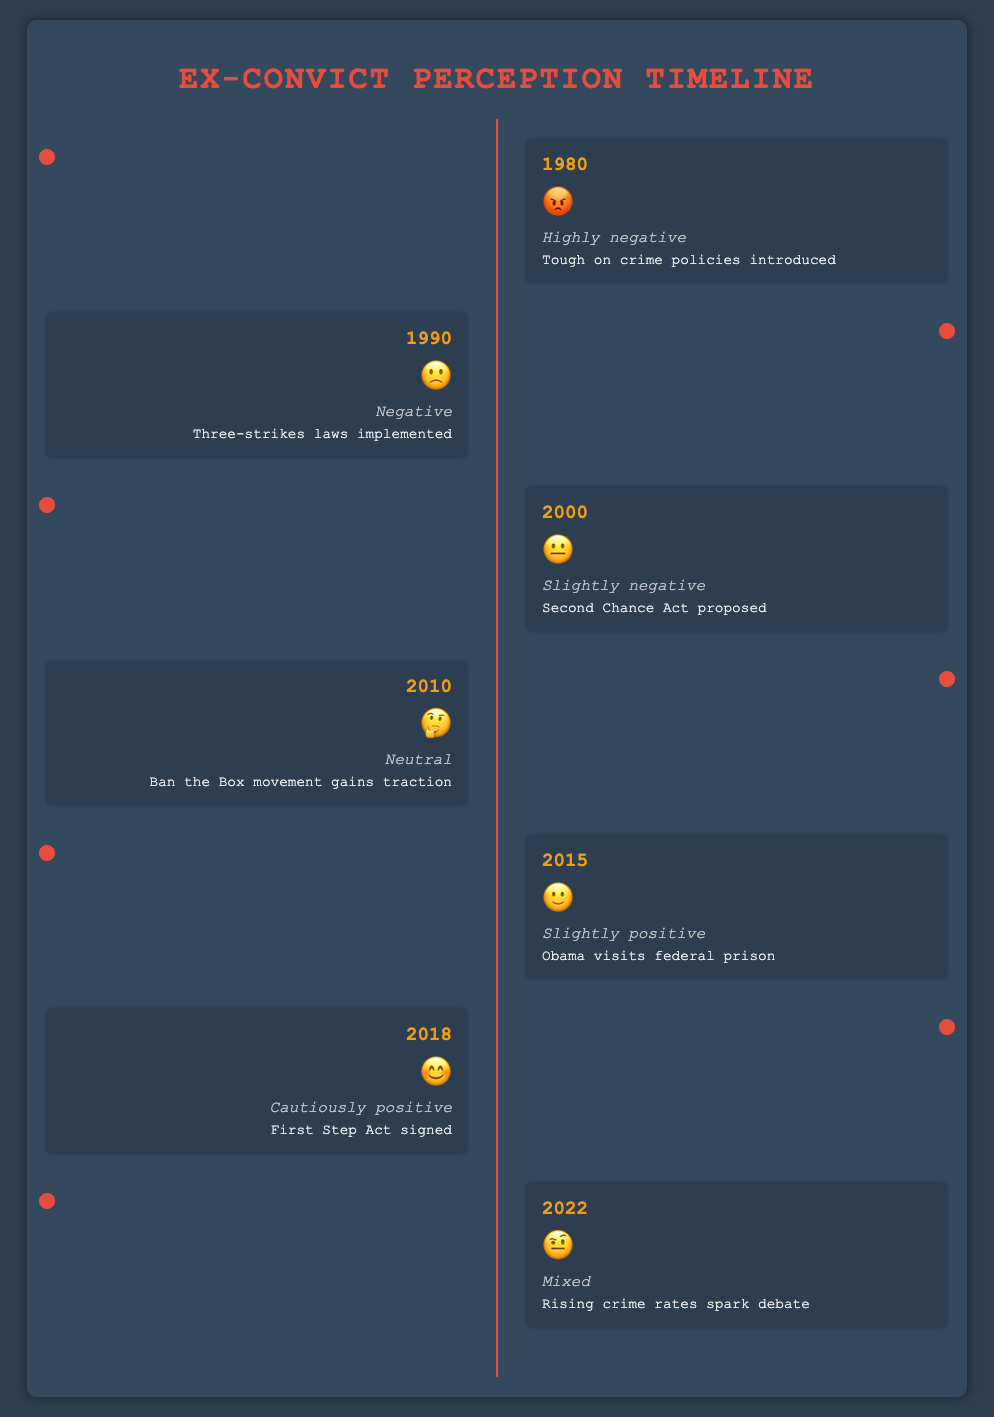Who introduced the "Tough on crime policies"? Referring to the figure, the event in 1980 mentions "Tough on crime policies introduced".
Answer: 1980 What was the public perception of ex-convicts in 2010? Referring to the figure, the year 2010 shows a neutral sentiment with the corresponding emoji "🤔".
Answer: Neutral Which year saw the implementation of the "Three-strikes laws"? Referring to the figure, the event in 1990 mentions "Three-strikes laws implemented".
Answer: 1990 How did public perception change between 2000 and 2018? Between 2000 and 2018, the perception moved from "Slightly negative (😐)" in 2000 to "Cautiously positive (😊)" in 2018. This indicates an improvement in public perception over time.
Answer: Improved Which year corresponds to the start of the "Ban the Box" movement? Referring to the figure, the event in 2010 mentions "Ban the Box movement gains traction".
Answer: 2010 What's the general trend in sentiment from 1980 to 2015? From 1980 to 2015, the sentiment improves from "Highly negative (😡)" to "Slightly positive (🙂)". This general trend shows an improvement in public perception over time.
Answer: Improvement Compare the public perception in 1980 and 2022. Which year had a more negative perception? In 1980, the sentiment was "Highly negative (😡)", and in 2022, it was "Mixed (🤨)". Therefore, 1980 had a more negative perception.
Answer: 1980 What sentiment is associated with the event "Obama visits federal prison"? Referring to the figure, the event in 2015 with "Obama visits federal prison" has a "Slightly positive (🙂)" sentiment.
Answer: Slightly positive In which year did the "First Step Act" get signed, and what was the public sentiment? Referring to the figure, the "First Step Act signed" event occurred in 2018, with a "Cautiously positive (😊)" sentiment.
Answer: 2018, Cautiously positive 